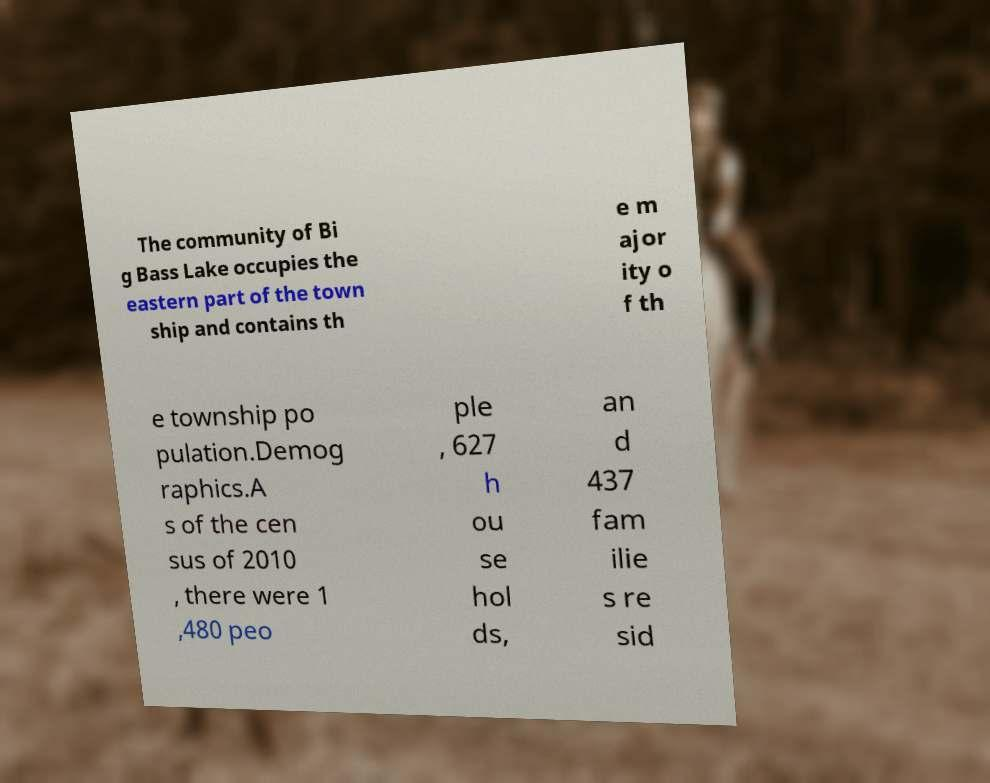Could you extract and type out the text from this image? The community of Bi g Bass Lake occupies the eastern part of the town ship and contains th e m ajor ity o f th e township po pulation.Demog raphics.A s of the cen sus of 2010 , there were 1 ,480 peo ple , 627 h ou se hol ds, an d 437 fam ilie s re sid 